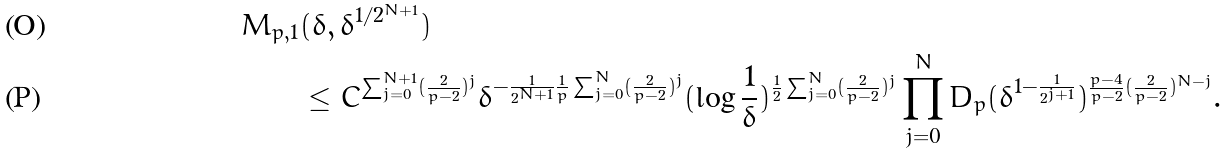Convert formula to latex. <formula><loc_0><loc_0><loc_500><loc_500>M _ { p , 1 } & ( \delta , \delta ^ { 1 / 2 ^ { N + 1 } } ) \\ & \leq C ^ { \sum _ { j = 0 } ^ { N + 1 } ( \frac { 2 } { p - 2 } ) ^ { j } } \delta ^ { - \frac { 1 } { 2 ^ { N + 1 } } \frac { 1 } { p } \sum _ { j = 0 } ^ { N } ( \frac { 2 } { p - 2 } ) ^ { j } } ( \log \frac { 1 } { \delta } ) ^ { \frac { 1 } { 2 } \sum _ { j = 0 } ^ { N } ( \frac { 2 } { p - 2 } ) ^ { j } } \prod _ { j = 0 } ^ { N } D _ { p } ( \delta ^ { 1 - \frac { 1 } { 2 ^ { j + 1 } } } ) ^ { \frac { p - 4 } { p - 2 } ( \frac { 2 } { p - 2 } ) ^ { N - j } } .</formula> 